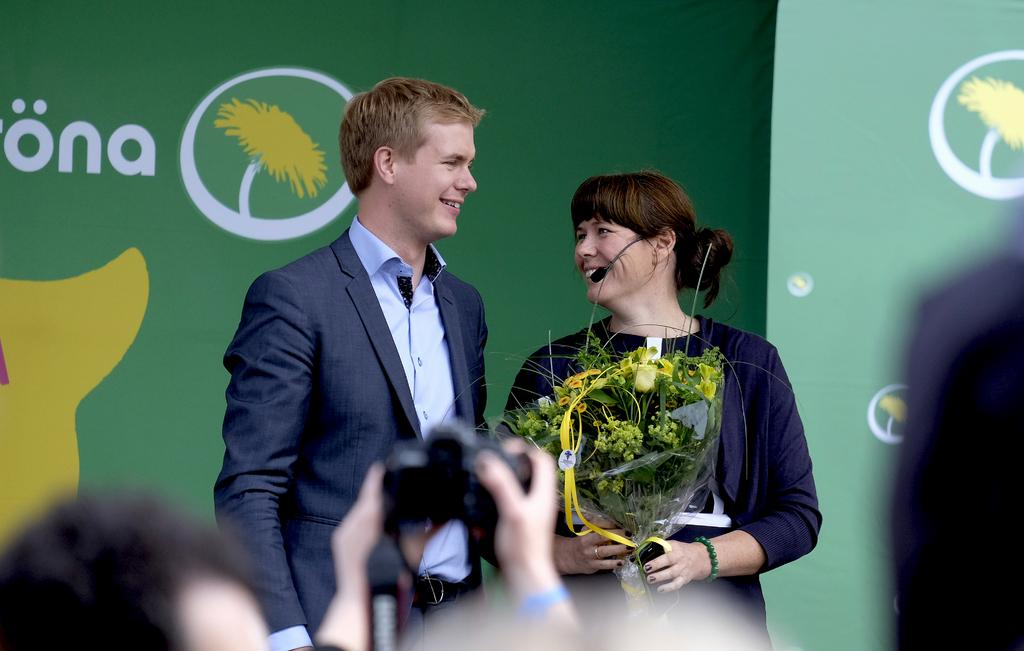How many people are in the image? There are two people in the image. What are the expressions on their faces? Both people are smiling in the image. What are the people doing in the image? The people are looking at each other. What is the woman holding in the image? The woman is holding a bouquet. What color is the background of the image? The background of the image is green. Can you see a snail carrying a pail in the image? No, there is no snail or pail present in the image. Is there a glass object visible in the image? There is no glass object visible in the image. 